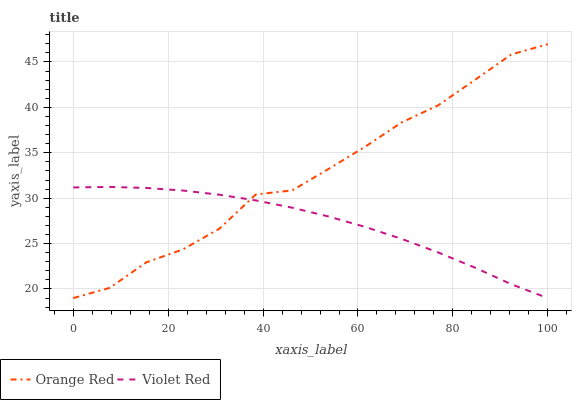Does Violet Red have the minimum area under the curve?
Answer yes or no. Yes. Does Orange Red have the maximum area under the curve?
Answer yes or no. Yes. Does Orange Red have the minimum area under the curve?
Answer yes or no. No. Is Violet Red the smoothest?
Answer yes or no. Yes. Is Orange Red the roughest?
Answer yes or no. Yes. Is Orange Red the smoothest?
Answer yes or no. No. Does Violet Red have the lowest value?
Answer yes or no. Yes. Does Orange Red have the highest value?
Answer yes or no. Yes. Does Violet Red intersect Orange Red?
Answer yes or no. Yes. Is Violet Red less than Orange Red?
Answer yes or no. No. Is Violet Red greater than Orange Red?
Answer yes or no. No. 